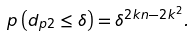<formula> <loc_0><loc_0><loc_500><loc_500>p \left ( { { d _ { p 2 } } \leq \delta } \right ) = { \delta ^ { 2 k n - 2 { k ^ { 2 } } } } .</formula> 